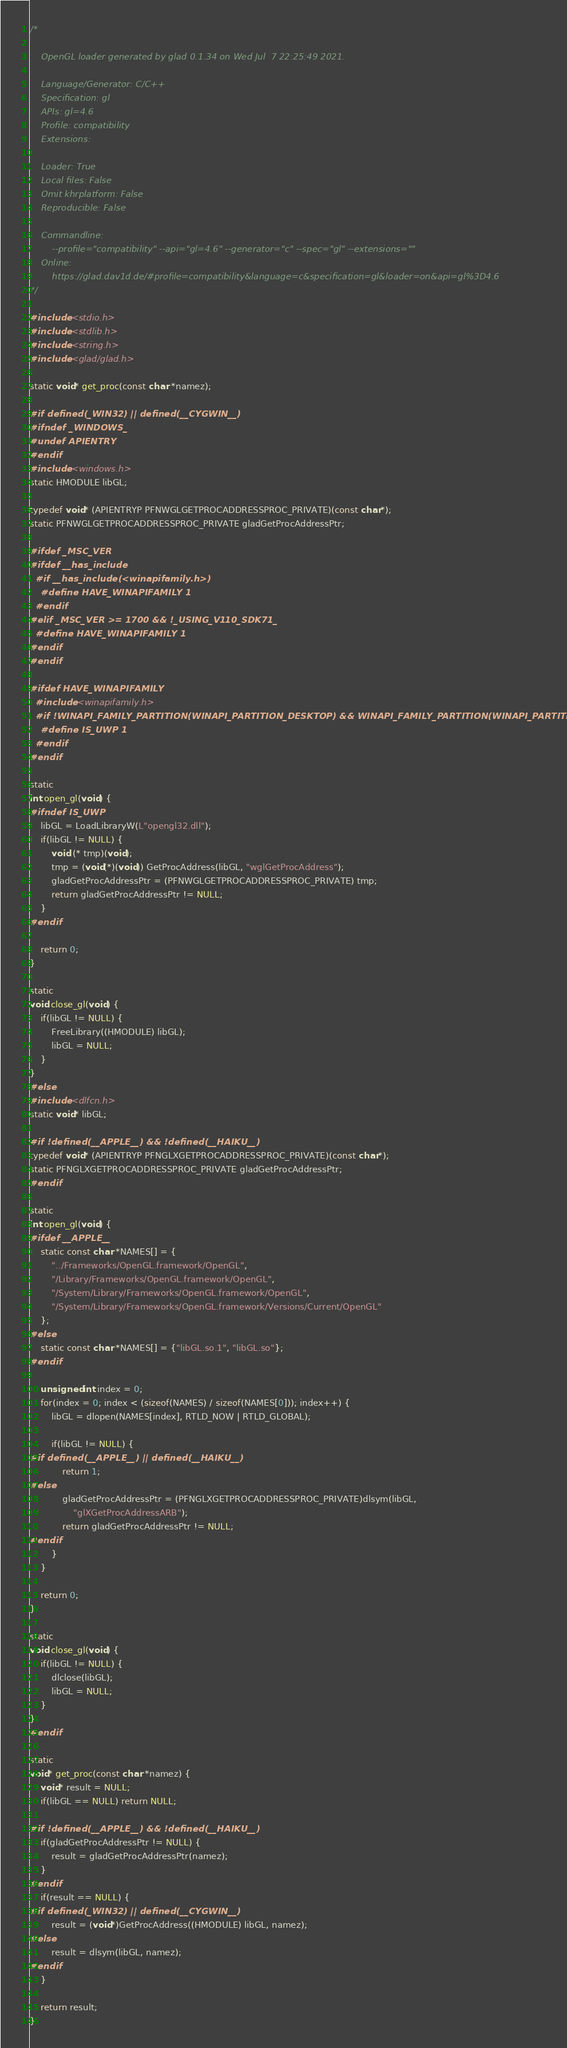Convert code to text. <code><loc_0><loc_0><loc_500><loc_500><_C_>/*

    OpenGL loader generated by glad 0.1.34 on Wed Jul  7 22:25:49 2021.

    Language/Generator: C/C++
    Specification: gl
    APIs: gl=4.6
    Profile: compatibility
    Extensions:
        
    Loader: True
    Local files: False
    Omit khrplatform: False
    Reproducible: False

    Commandline:
        --profile="compatibility" --api="gl=4.6" --generator="c" --spec="gl" --extensions=""
    Online:
        https://glad.dav1d.de/#profile=compatibility&language=c&specification=gl&loader=on&api=gl%3D4.6
*/

#include <stdio.h>
#include <stdlib.h>
#include <string.h>
#include <glad/glad.h>

static void* get_proc(const char *namez);

#if defined(_WIN32) || defined(__CYGWIN__)
#ifndef _WINDOWS_
#undef APIENTRY
#endif
#include <windows.h>
static HMODULE libGL;

typedef void* (APIENTRYP PFNWGLGETPROCADDRESSPROC_PRIVATE)(const char*);
static PFNWGLGETPROCADDRESSPROC_PRIVATE gladGetProcAddressPtr;

#ifdef _MSC_VER
#ifdef __has_include
  #if __has_include(<winapifamily.h>)
    #define HAVE_WINAPIFAMILY 1
  #endif
#elif _MSC_VER >= 1700 && !_USING_V110_SDK71_
  #define HAVE_WINAPIFAMILY 1
#endif
#endif

#ifdef HAVE_WINAPIFAMILY
  #include <winapifamily.h>
  #if !WINAPI_FAMILY_PARTITION(WINAPI_PARTITION_DESKTOP) && WINAPI_FAMILY_PARTITION(WINAPI_PARTITION_APP)
    #define IS_UWP 1
  #endif
#endif

static
int open_gl(void) {
#ifndef IS_UWP
    libGL = LoadLibraryW(L"opengl32.dll");
    if(libGL != NULL) {
        void (* tmp)(void);
        tmp = (void(*)(void)) GetProcAddress(libGL, "wglGetProcAddress");
        gladGetProcAddressPtr = (PFNWGLGETPROCADDRESSPROC_PRIVATE) tmp;
        return gladGetProcAddressPtr != NULL;
    }
#endif

    return 0;
}

static
void close_gl(void) {
    if(libGL != NULL) {
        FreeLibrary((HMODULE) libGL);
        libGL = NULL;
    }
}
#else
#include <dlfcn.h>
static void* libGL;

#if !defined(__APPLE__) && !defined(__HAIKU__)
typedef void* (APIENTRYP PFNGLXGETPROCADDRESSPROC_PRIVATE)(const char*);
static PFNGLXGETPROCADDRESSPROC_PRIVATE gladGetProcAddressPtr;
#endif

static
int open_gl(void) {
#ifdef __APPLE__
    static const char *NAMES[] = {
        "../Frameworks/OpenGL.framework/OpenGL",
        "/Library/Frameworks/OpenGL.framework/OpenGL",
        "/System/Library/Frameworks/OpenGL.framework/OpenGL",
        "/System/Library/Frameworks/OpenGL.framework/Versions/Current/OpenGL"
    };
#else
    static const char *NAMES[] = {"libGL.so.1", "libGL.so"};
#endif

    unsigned int index = 0;
    for(index = 0; index < (sizeof(NAMES) / sizeof(NAMES[0])); index++) {
        libGL = dlopen(NAMES[index], RTLD_NOW | RTLD_GLOBAL);

        if(libGL != NULL) {
#if defined(__APPLE__) || defined(__HAIKU__)
            return 1;
#else
            gladGetProcAddressPtr = (PFNGLXGETPROCADDRESSPROC_PRIVATE)dlsym(libGL,
                "glXGetProcAddressARB");
            return gladGetProcAddressPtr != NULL;
#endif
        }
    }

    return 0;
}

static
void close_gl(void) {
    if(libGL != NULL) {
        dlclose(libGL);
        libGL = NULL;
    }
}
#endif

static
void* get_proc(const char *namez) {
    void* result = NULL;
    if(libGL == NULL) return NULL;

#if !defined(__APPLE__) && !defined(__HAIKU__)
    if(gladGetProcAddressPtr != NULL) {
        result = gladGetProcAddressPtr(namez);
    }
#endif
    if(result == NULL) {
#if defined(_WIN32) || defined(__CYGWIN__)
        result = (void*)GetProcAddress((HMODULE) libGL, namez);
#else
        result = dlsym(libGL, namez);
#endif
    }

    return result;
}
</code> 